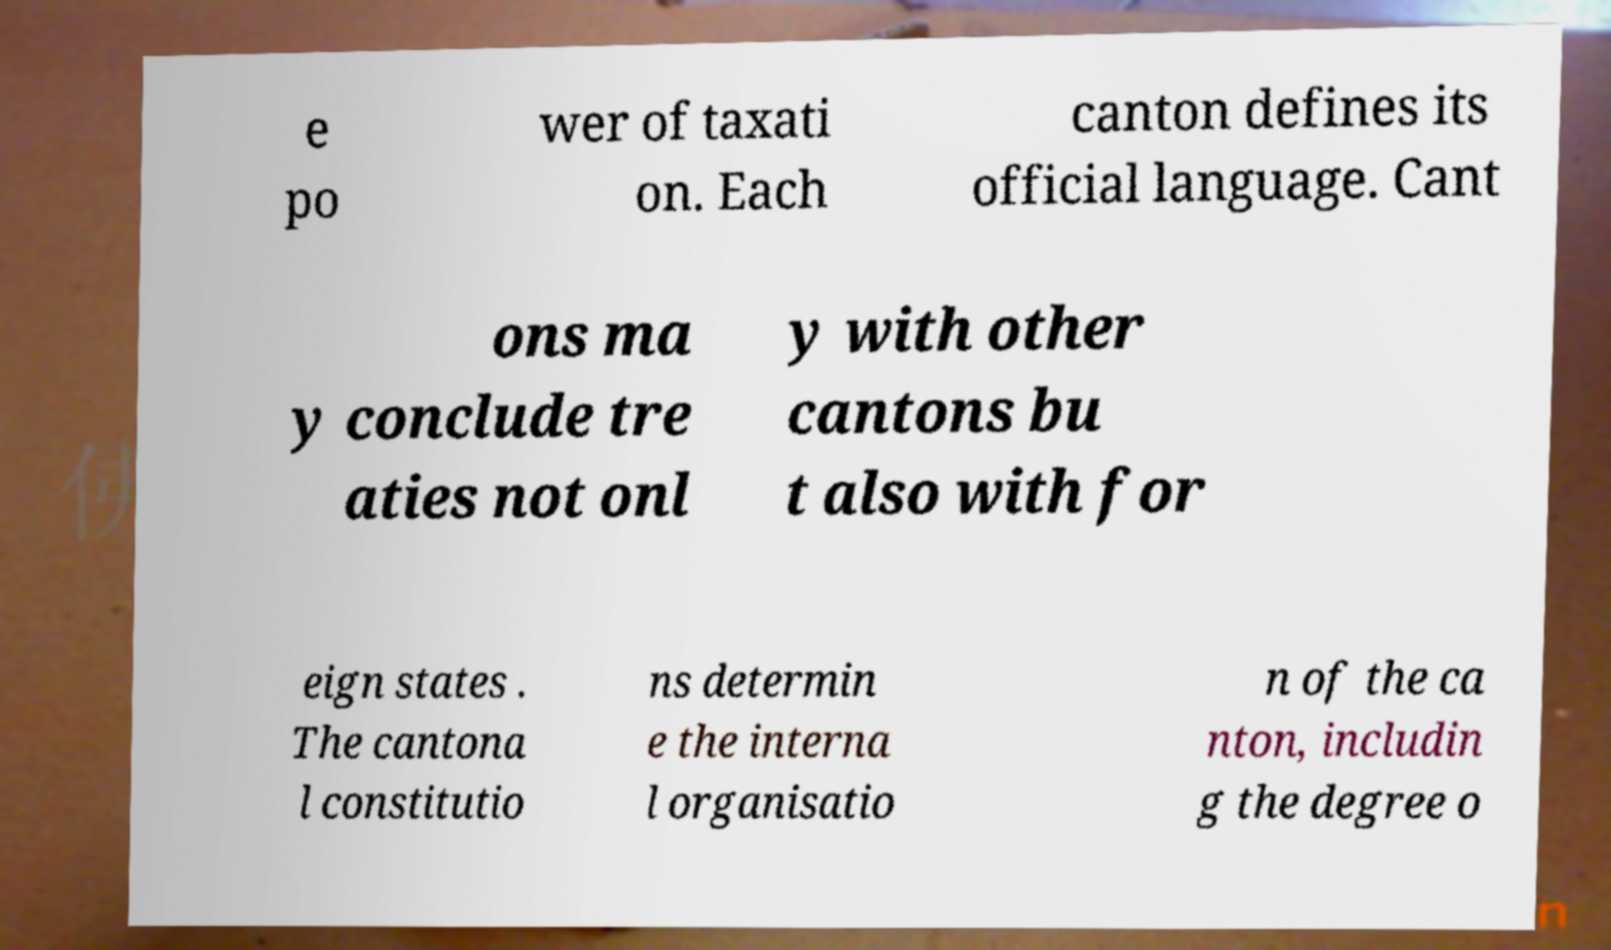Please read and relay the text visible in this image. What does it say? e po wer of taxati on. Each canton defines its official language. Cant ons ma y conclude tre aties not onl y with other cantons bu t also with for eign states . The cantona l constitutio ns determin e the interna l organisatio n of the ca nton, includin g the degree o 